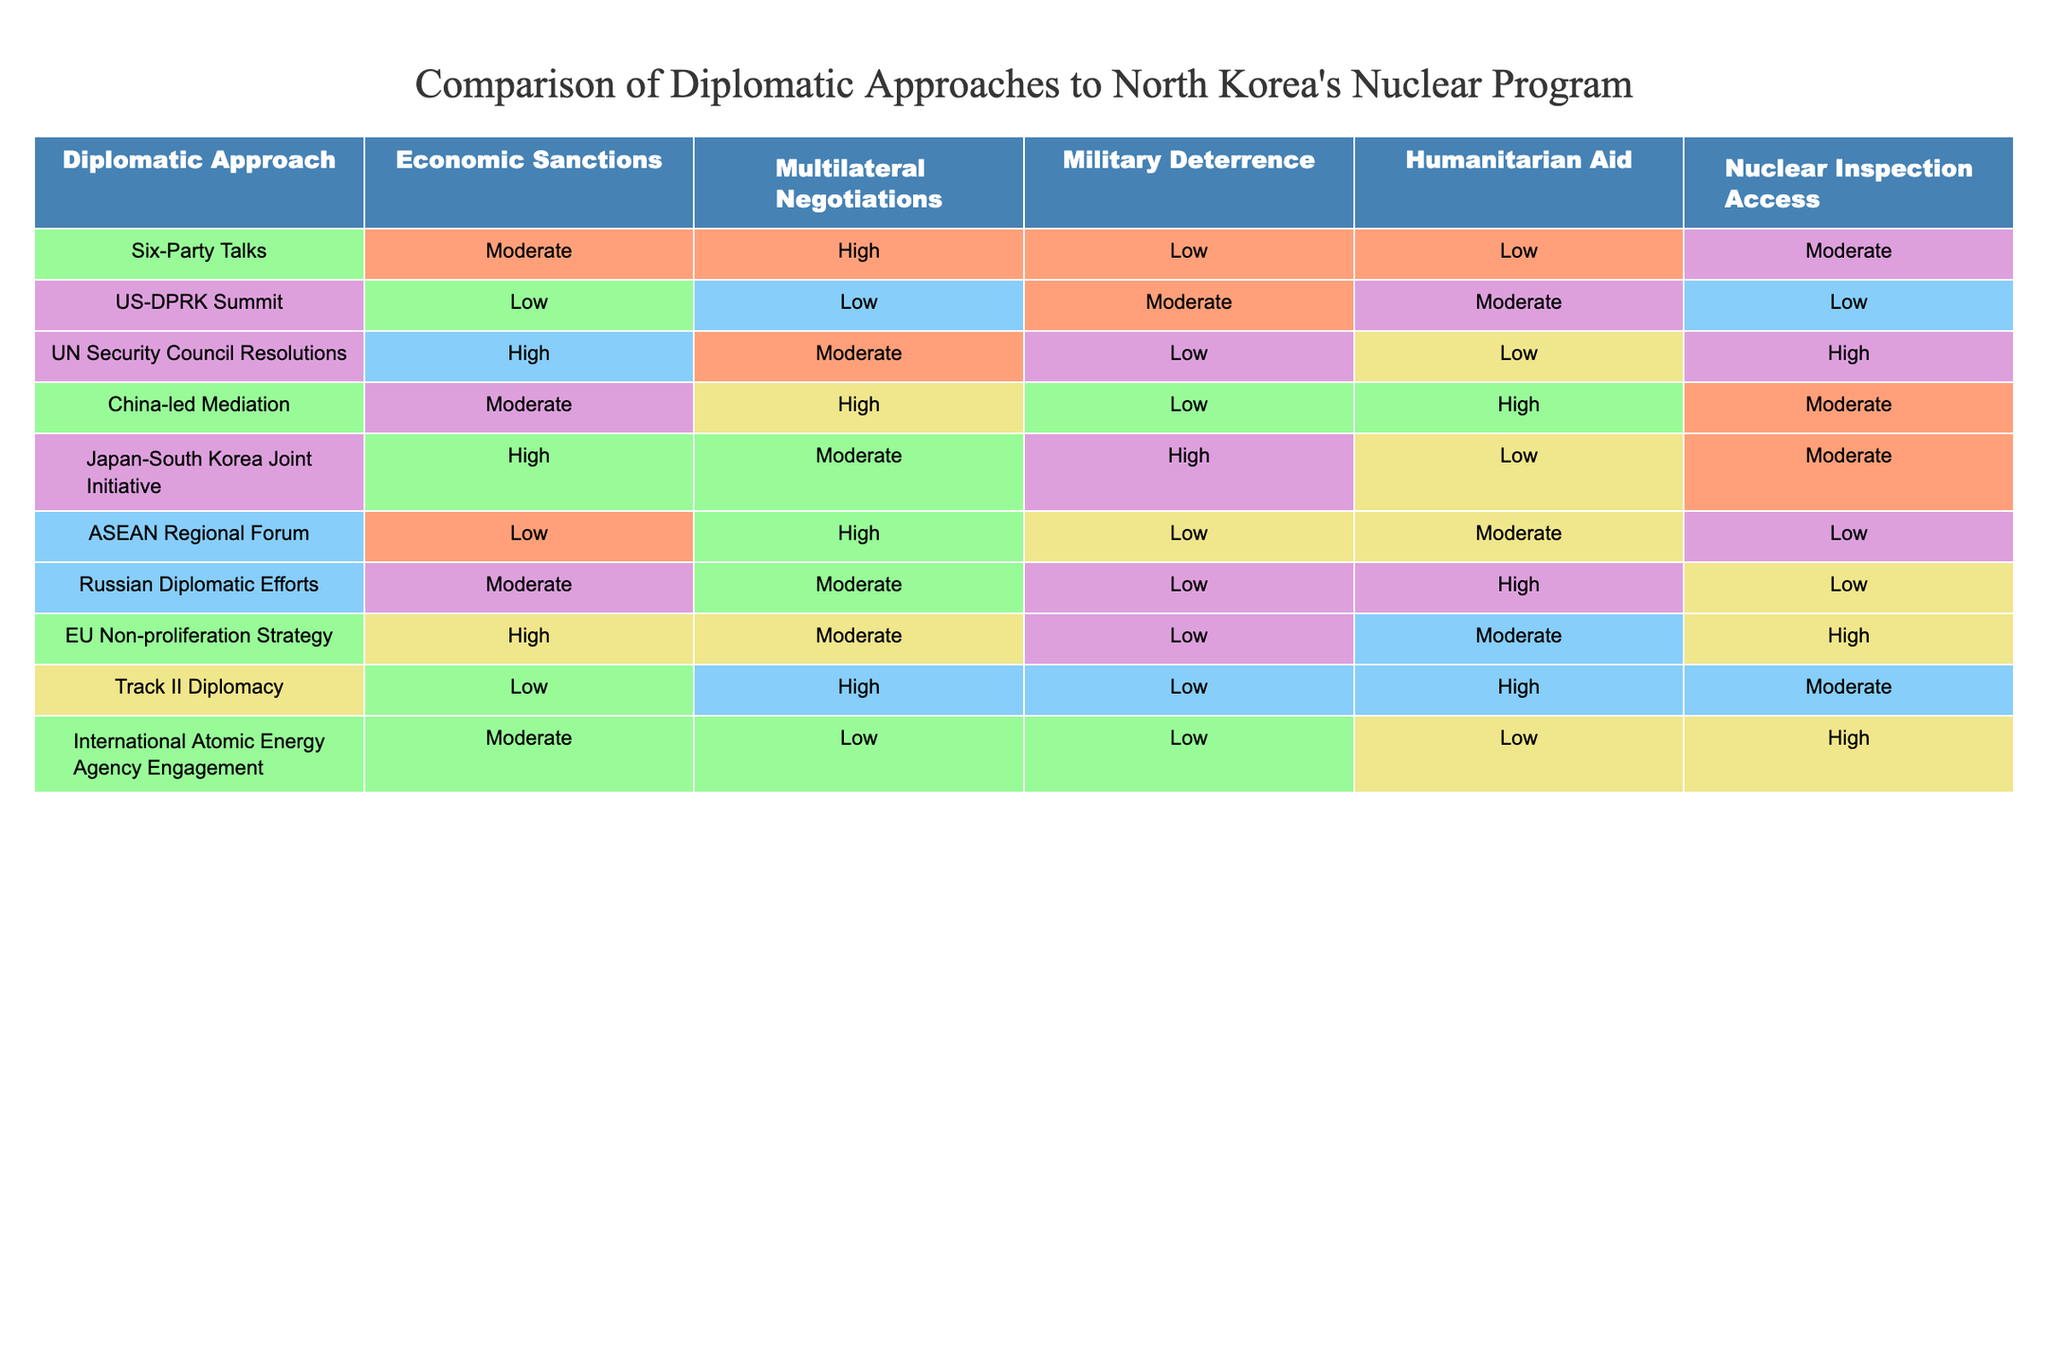What is the highest rating for Economic Sanctions among the diplomatic approaches? The highest rating for Economic Sanctions in the table is "High". This rating appears for the diplomatic approaches of UN Security Council Resolutions, Japan-South Korea Joint Initiative, and EU Non-proliferation Strategy. It indicates that these approaches utilize economic sanctions as a significant method in dealing with North Korea's nuclear program.
Answer: High Which diplomatic approach has the lowest rating for Military Deterrence? The approach with the lowest rating for Military Deterrence is the UN Security Council Resolutions, with a "Low" rating. This indicates that the approach does not heavily rely on military deterrence as a strategy in addressing North Korea's nuclear program.
Answer: Low Are there any diplomatic approaches that provide both High Economic Sanctions and High Humanitarian Aid ratings? Upon reviewing the table, there are no diplomatic approaches that have both High ratings in Economic Sanctions and Humanitarian Aid. Each approach tends to favor one over the other based on the strategies they propose.
Answer: No What is the average rating for Nuclear Inspection Access among all the approaches? To calculate the average rating for Nuclear Inspection Access, we assign numeric values: Low = 1, Moderate = 2, High = 3. Adding the values gives 2+1+3+2+2+1+1+3+2+3 = 20. There are 10 approaches, so the average rating is 20/10 = 2, which corresponds to "Moderate".
Answer: Moderate Which diplomatic approach shows a strong focus on Multilateral Negotiations? The diplomatic approaches showing a strong focus on Multilateral Negotiations with a "High" rating are Six-Party Talks, China-led Mediation, and ASEAN Regional Forum. This suggests that these approaches advocate significantly for negotiation strategies with multiple parties involved.
Answer: Six-Party Talks, China-led Mediation, ASEAN Regional Forum Is the US-DPRK Summit effective in providing Nuclear Inspection Access? The US-DPRK Summit has a rating of "Low" for Nuclear Inspection Access, indicating it is not effective in facilitating access for inspections concerning North Korea's nuclear capabilities.
Answer: No What combination of approaches yields the highest score when adding their ratings for Economic Sanctions and Multilateral Negotiations? The highest scoring combination is the Japan-South Korea Joint Initiative (High Economic Sanctions + Moderate Multilateral Negotiations) which equals a combined score of 4 (3 for High and 2 for Moderate).
Answer: Japan-South Korea Joint Initiative Which approach provides the highest ratings for both Humanitarian Aid and Nuclear Inspection Access? The China-led Mediation approach provides a "High" rating in Humanitarian Aid and "Moderate" in Nuclear Inspection Access. Thus, while it is very supportive of humanitarian efforts, it does not provide the highest for Nuclear Inspection.
Answer: No single approach provides the highest for both 